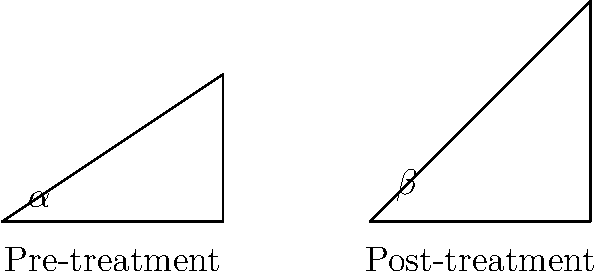The stick figure drawings show the flexibility improvement of a patient before and after undergoing rehabilitation. If the pre-treatment angle $\alpha$ is 33.7°, and the post-treatment angle $\beta$ is 50.2°, what is the percentage increase in flexibility? To calculate the percentage increase in flexibility, we'll follow these steps:

1. Calculate the difference between the post-treatment and pre-treatment angles:
   $\Delta \text{angle} = \beta - \alpha = 50.2° - 33.7° = 16.5°$

2. Calculate the percentage increase using the formula:
   $\text{Percentage increase} = \frac{\text{Increase}}{\text{Original}} \times 100\%$

   $\text{Percentage increase} = \frac{\Delta \text{angle}}{\alpha} \times 100\%$

3. Plug in the values:
   $\text{Percentage increase} = \frac{16.5°}{33.7°} \times 100\%$

4. Perform the calculation:
   $\text{Percentage increase} = 0.4896 \times 100\% = 48.96\%$

5. Round to the nearest whole percentage:
   $\text{Percentage increase} \approx 49\%$

Therefore, the flexibility increased by approximately 49%.
Answer: 49% 